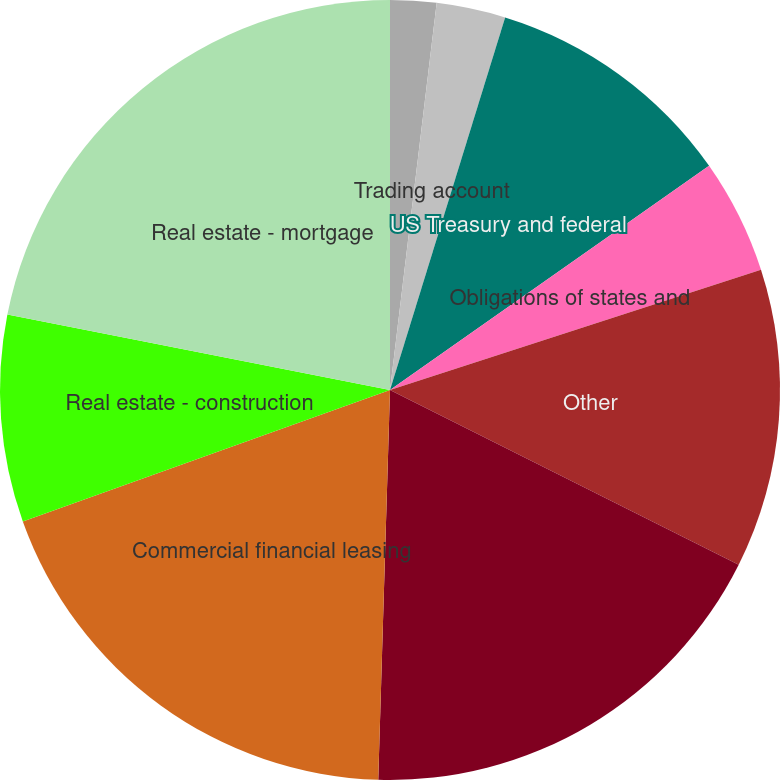Convert chart. <chart><loc_0><loc_0><loc_500><loc_500><pie_chart><fcel>Interest-bearing deposits at<fcel>Federal funds sold<fcel>Trading account<fcel>US Treasury and federal<fcel>Obligations of states and<fcel>Other<fcel>Total investment securities<fcel>Commercial financial leasing<fcel>Real estate - construction<fcel>Real estate - mortgage<nl><fcel>0.0%<fcel>1.91%<fcel>2.86%<fcel>10.48%<fcel>4.76%<fcel>12.38%<fcel>18.09%<fcel>19.05%<fcel>8.57%<fcel>21.9%<nl></chart> 